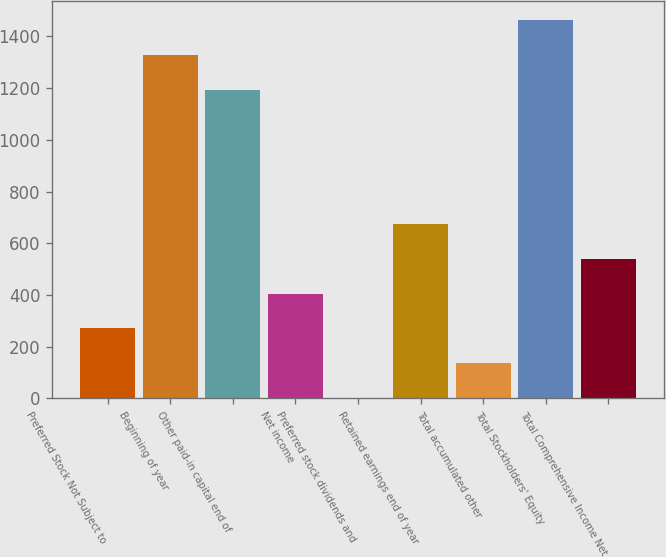<chart> <loc_0><loc_0><loc_500><loc_500><bar_chart><fcel>Preferred Stock Not Subject to<fcel>Beginning of year<fcel>Other paid-in capital end of<fcel>Net income<fcel>Preferred stock dividends and<fcel>Retained earnings end of year<fcel>Total accumulated other<fcel>Total Stockholders' Equity<fcel>Total Comprehensive Income Net<nl><fcel>270.8<fcel>1328.4<fcel>1194<fcel>405.2<fcel>2<fcel>674<fcel>136.4<fcel>1462.8<fcel>539.6<nl></chart> 